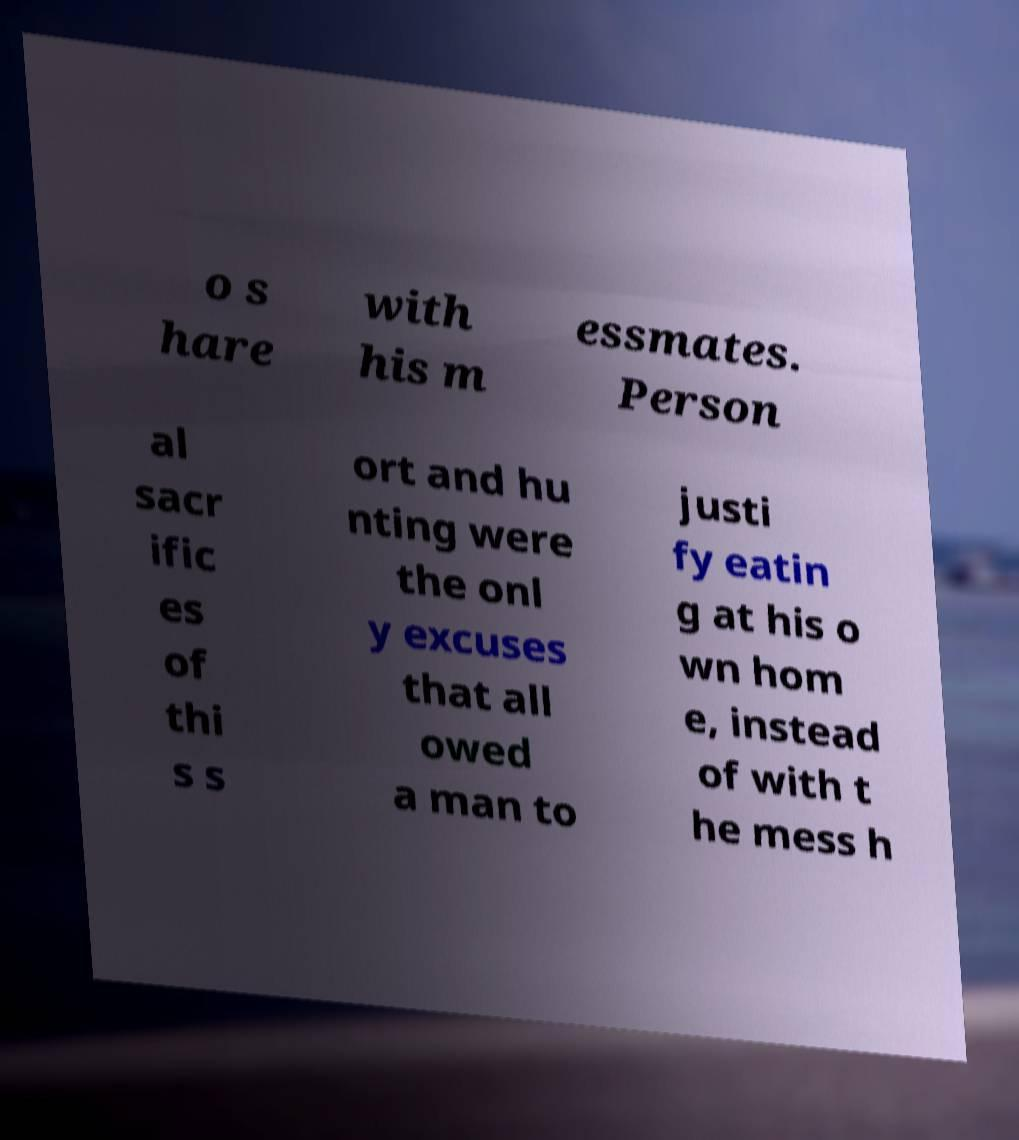There's text embedded in this image that I need extracted. Can you transcribe it verbatim? o s hare with his m essmates. Person al sacr ific es of thi s s ort and hu nting were the onl y excuses that all owed a man to justi fy eatin g at his o wn hom e, instead of with t he mess h 